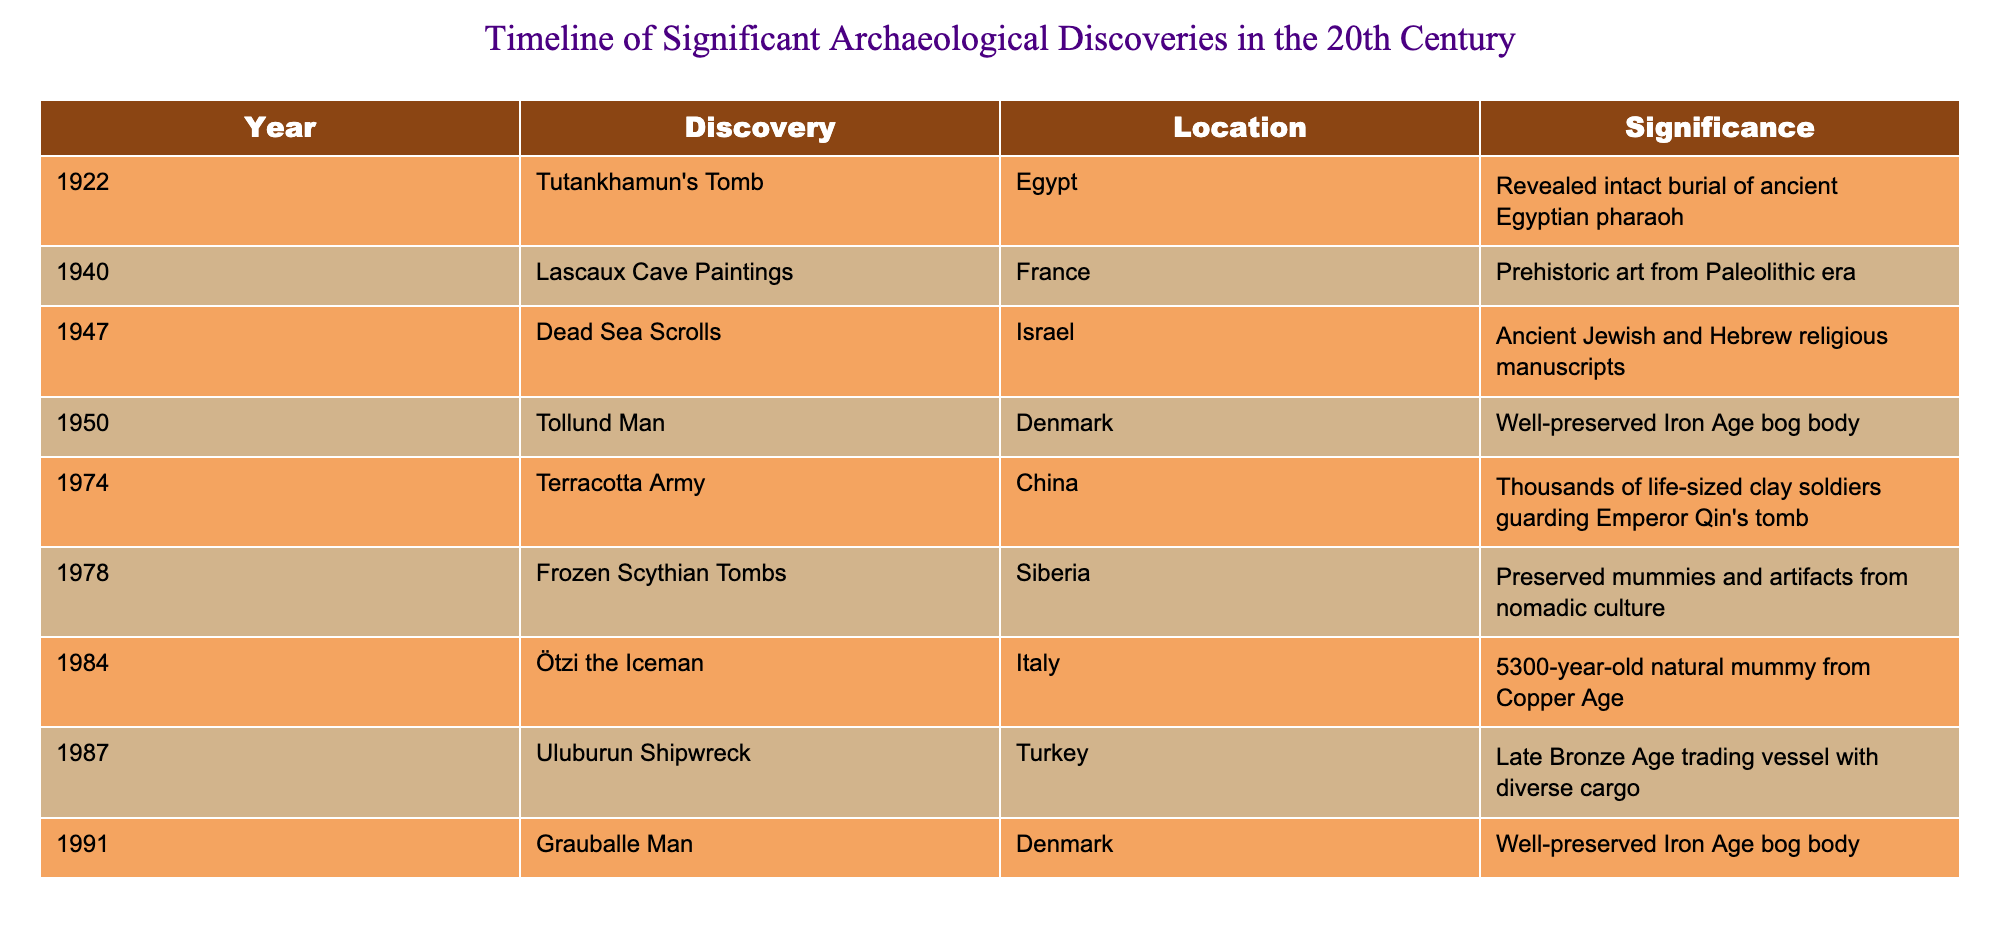What year was Tutankhamun's Tomb discovered? Tutankhamun's Tomb is listed in the table under the "Year" column. It is noted that it was discovered in 1922.
Answer: 1922 What significant discovery occurred in 1947? The significant discovery listed for 1947 in the table is the Dead Sea Scrolls. This is directly referenced in the table under the corresponding year.
Answer: Dead Sea Scrolls How many discoveries were made in the 1970s? From the table, there are three discoveries listed in the 1970s: the Terracotta Army (1974), the Frozen Scythian Tombs (1978), and the Grauballe Man (1991), making a total of three significant discoveries.
Answer: 3 Were any of these discoveries related to preserved human remains? Yes, the Tollund Man (1950), the Frozen Scythian Tombs (1978), and Grauballe Man (1991) are all related to well-preserved human remains as indicated in their descriptions in the table.
Answer: Yes Which discovery has the earliest date among the well-preserved bog bodies? The earliest discovered well-preserved bog body listed in the table is the Tollund Man, discovered in 1950. To confirm, I check the dates of Tollund Man (1950), Grauballe Man (1991), and the note that they are bog bodies. The first among these is the Tollund Man.
Answer: Tollund Man What was the significance of the Uluburun Shipwreck? The Uluburun Shipwreck's significance is that it was a Late Bronze Age trading vessel with diverse cargo. This is directly stated in the significance column next to the discovery in the table under the relevant year (1987).
Answer: Late Bronze Age trading vessel with diverse cargo Which discovery occurred in Italy and what is its significance? The discovery that occurred in Italy is Ötzi the Iceman, which is noted to be a 5300-year-old natural mummy from the Copper Age. This can be cross-checked in the table under the Country and Significance columns.
Answer: Ötzi the Iceman; 5300-year-old natural mummy from the Copper Age Which two discoveries are related to ancient cultures, and what are their respective years? The discoveries related to ancient cultures are Tutankhamun's Tomb (1922) and the Terracotta Army (1974). Tutankhamun's Tomb is tied to ancient Egyptian culture while the Terracotta Army is linked to the culture of ancient China. This is shown in the table when checking the significance and year columns for each.
Answer: Tutankhamun's Tomb (1922) and Terracotta Army (1974) 